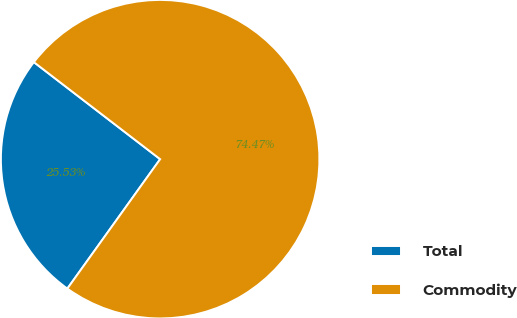<chart> <loc_0><loc_0><loc_500><loc_500><pie_chart><fcel>Total<fcel>Commodity<nl><fcel>25.53%<fcel>74.47%<nl></chart> 